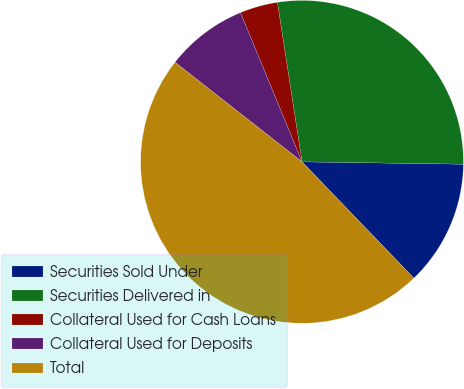<chart> <loc_0><loc_0><loc_500><loc_500><pie_chart><fcel>Securities Sold Under<fcel>Securities Delivered in<fcel>Collateral Used for Cash Loans<fcel>Collateral Used for Deposits<fcel>Total<nl><fcel>12.58%<fcel>27.67%<fcel>3.79%<fcel>8.19%<fcel>47.77%<nl></chart> 